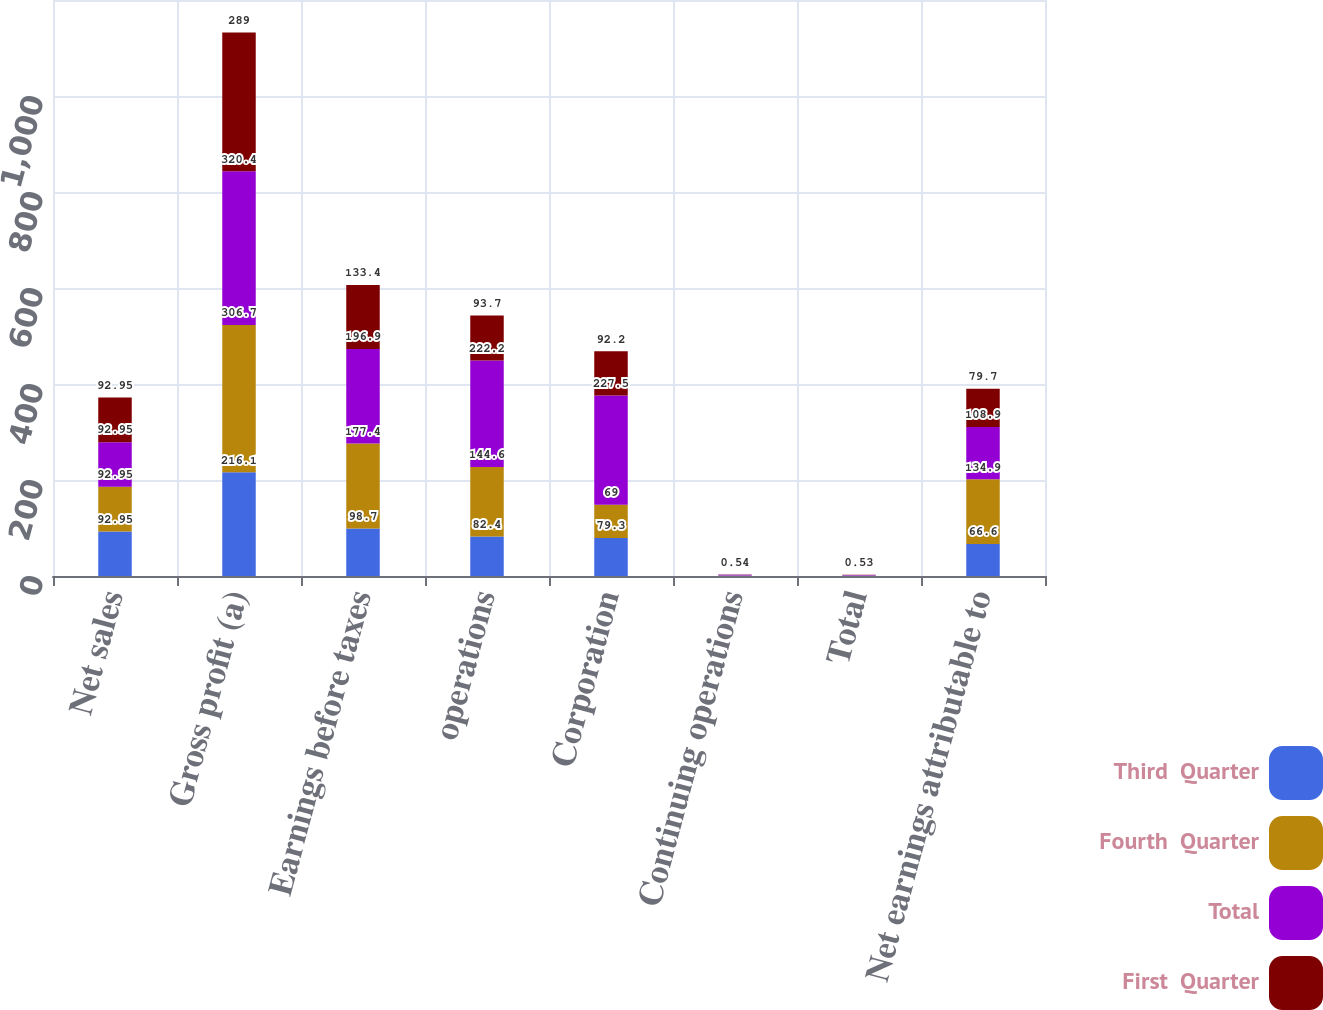Convert chart. <chart><loc_0><loc_0><loc_500><loc_500><stacked_bar_chart><ecel><fcel>Net sales<fcel>Gross profit (a)<fcel>Earnings before taxes<fcel>operations<fcel>Corporation<fcel>Continuing operations<fcel>Total<fcel>Net earnings attributable to<nl><fcel>Third  Quarter<fcel>92.95<fcel>216.1<fcel>98.7<fcel>82.4<fcel>79.3<fcel>0.44<fcel>0.43<fcel>66.6<nl><fcel>Fourth  Quarter<fcel>92.95<fcel>306.7<fcel>177.4<fcel>144.6<fcel>69<fcel>0.79<fcel>0.37<fcel>134.9<nl><fcel>Total<fcel>92.95<fcel>320.4<fcel>196.9<fcel>222.2<fcel>227.5<fcel>1.24<fcel>1.27<fcel>108.9<nl><fcel>First  Quarter<fcel>92.95<fcel>289<fcel>133.4<fcel>93.7<fcel>92.2<fcel>0.54<fcel>0.53<fcel>79.7<nl></chart> 